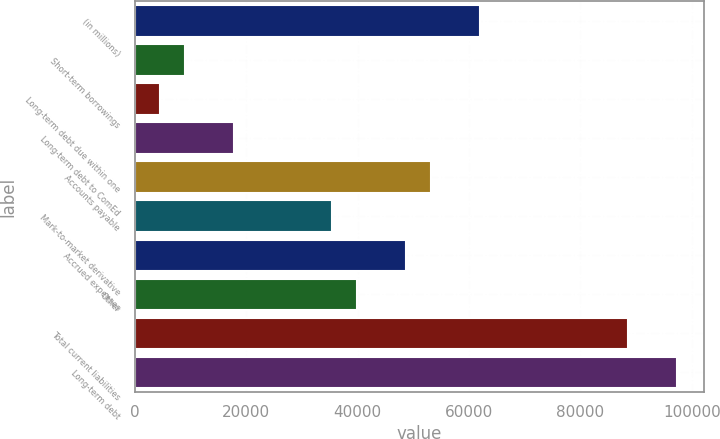<chart> <loc_0><loc_0><loc_500><loc_500><bar_chart><fcel>(in millions)<fcel>Short-term borrowings<fcel>Long-term debt due within one<fcel>Long-term debt to ComEd<fcel>Accounts payable<fcel>Mark-to-market derivative<fcel>Accrued expenses<fcel>Other<fcel>Total current liabilities<fcel>Long-term debt<nl><fcel>62011.8<fcel>8933.4<fcel>4510.2<fcel>17779.8<fcel>53165.4<fcel>35472.6<fcel>48742.2<fcel>39895.8<fcel>88551<fcel>97397.4<nl></chart> 